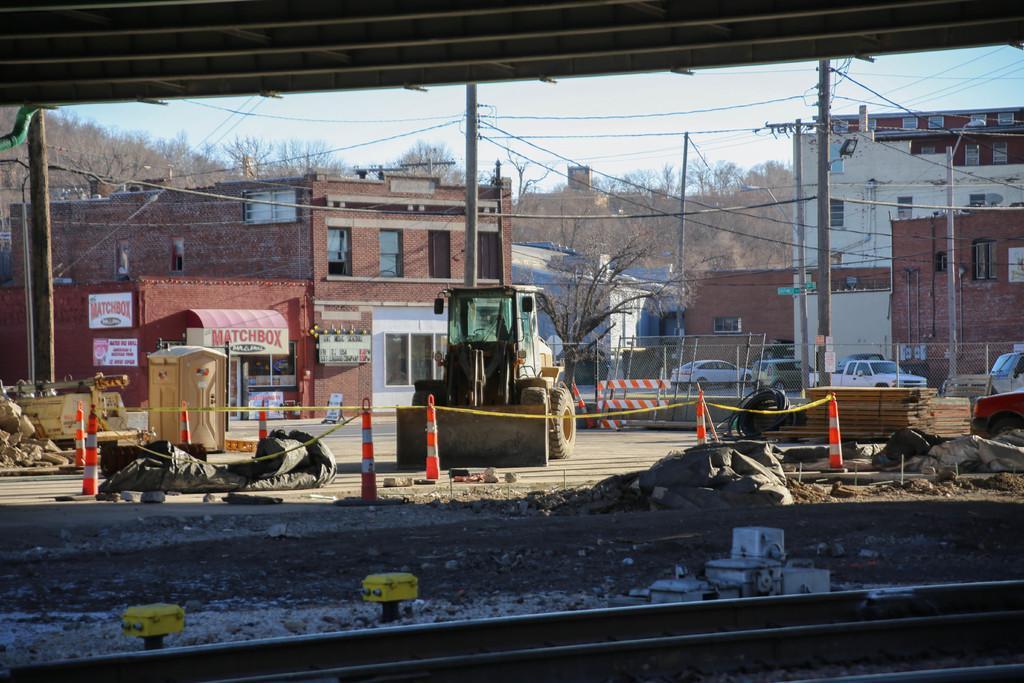Can you describe this image briefly? In this picture we can see a railway track. There are few tapes and stands. We can see a barricade. There is some fencing on the right side. We can see a few vehicles,a streetlight and few poles. Some wires are visible on top. There are some trees and buildings in the background. 